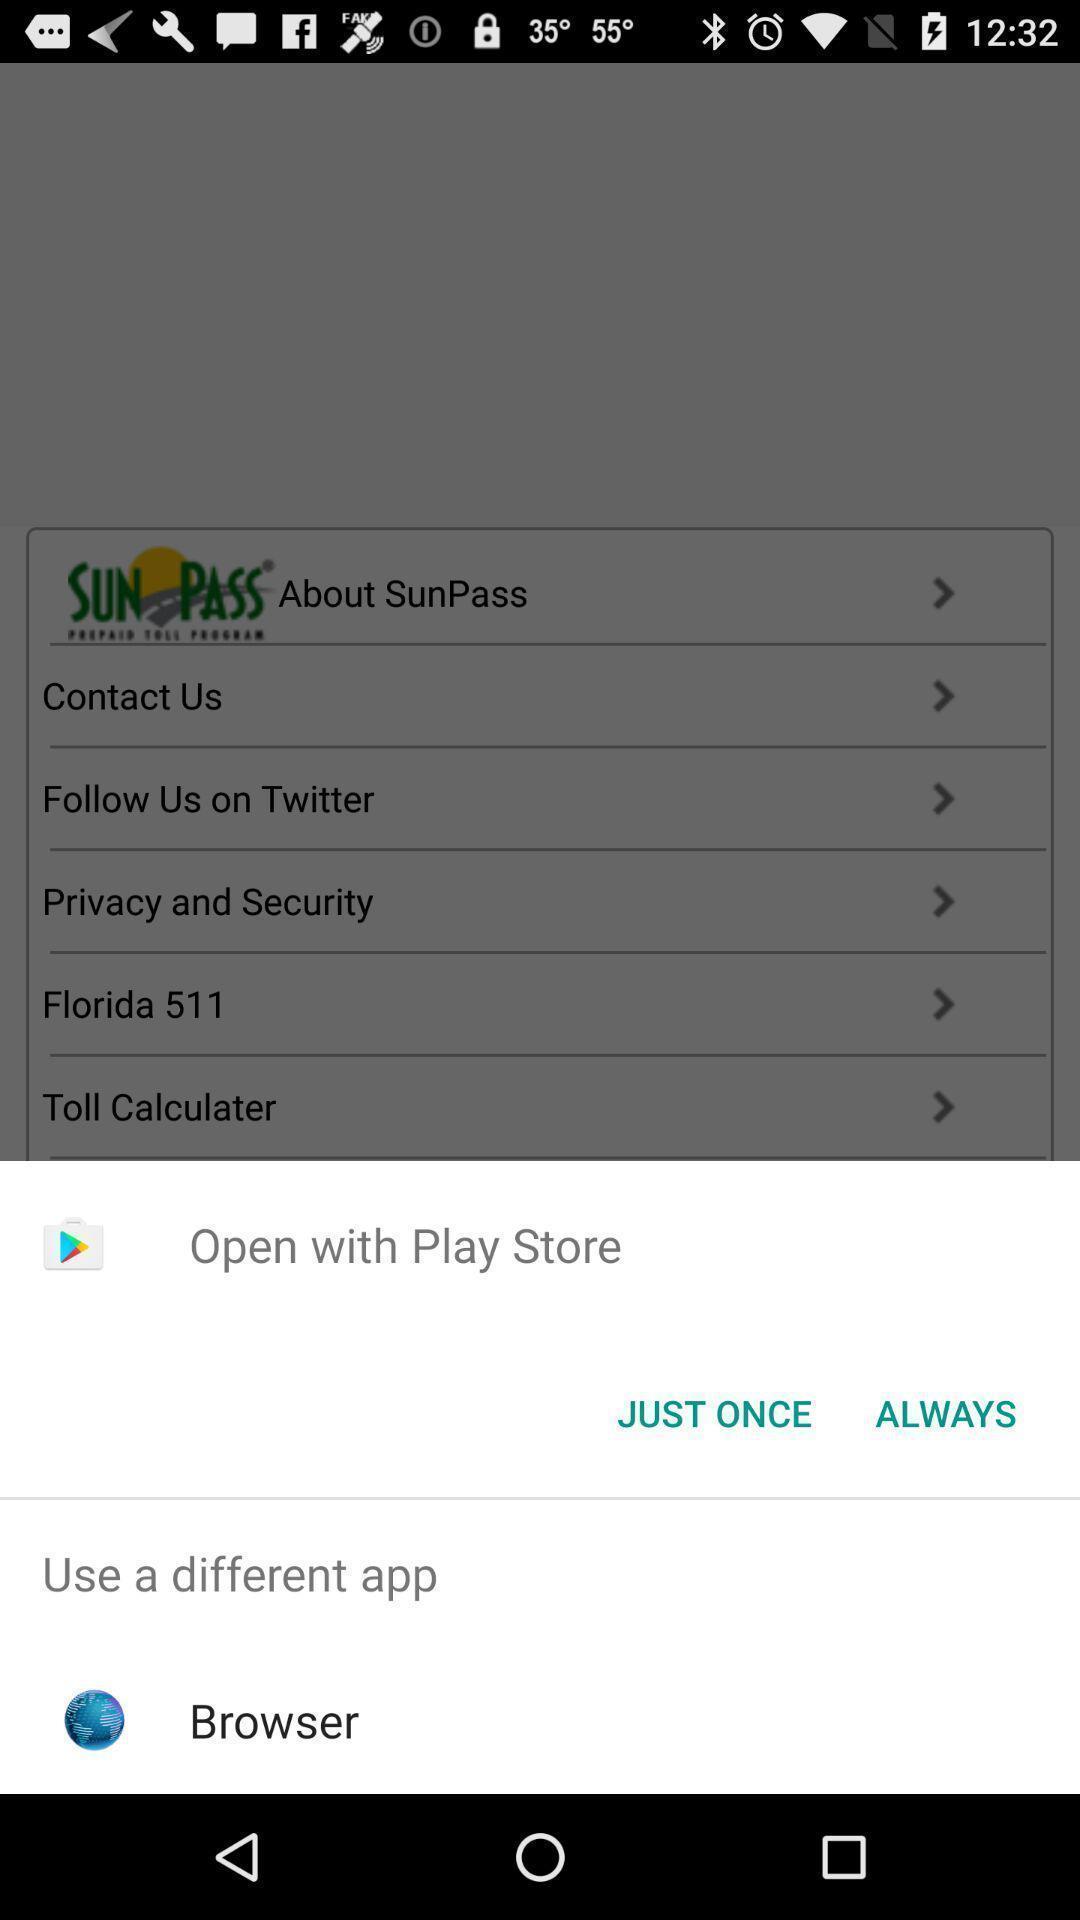What details can you identify in this image? Popup page for opening through different apps. 